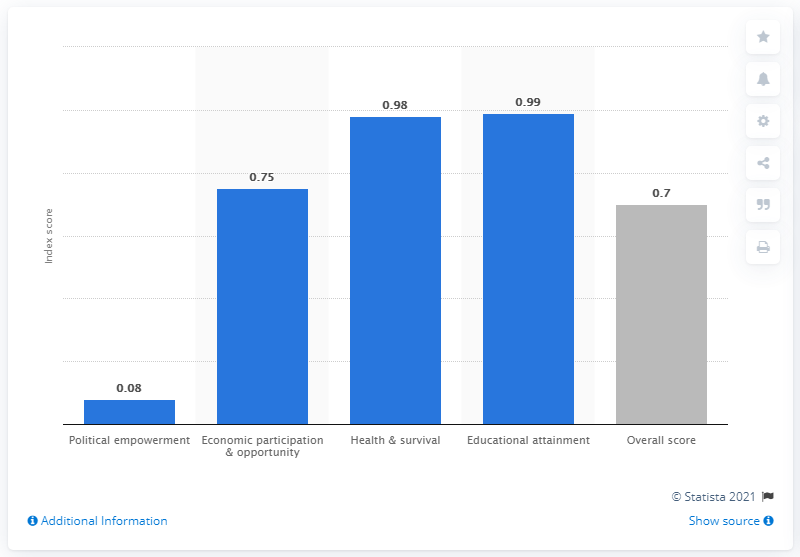Specify some key components in this picture. In 2021, Belize's score in the area of political empowerment was 0.08. 